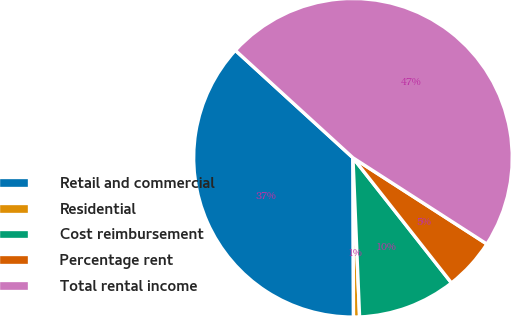Convert chart to OTSL. <chart><loc_0><loc_0><loc_500><loc_500><pie_chart><fcel>Retail and commercial<fcel>Residential<fcel>Cost reimbursement<fcel>Percentage rent<fcel>Total rental income<nl><fcel>36.83%<fcel>0.61%<fcel>9.95%<fcel>5.28%<fcel>47.32%<nl></chart> 